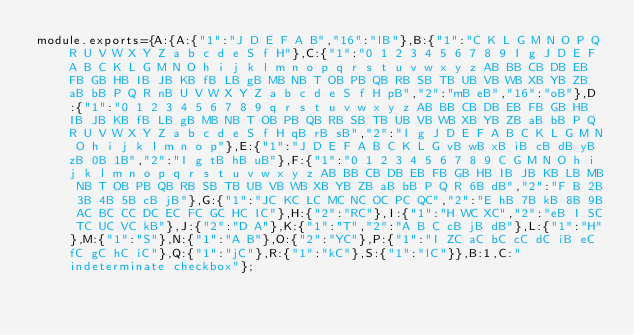<code> <loc_0><loc_0><loc_500><loc_500><_JavaScript_>module.exports={A:{A:{"1":"J D E F A B","16":"lB"},B:{"1":"C K L G M N O P Q R U V W X Y Z a b c d e S f H"},C:{"1":"0 1 2 3 4 5 6 7 8 9 I g J D E F A B C K L G M N O h i j k l m n o p q r s t u v w x y z AB BB CB DB EB FB GB HB IB JB KB fB LB gB MB NB T OB PB QB RB SB TB UB VB WB XB YB ZB aB bB P Q R nB U V W X Y Z a b c d e S f H pB","2":"mB eB","16":"oB"},D:{"1":"0 1 2 3 4 5 6 7 8 9 q r s t u v w x y z AB BB CB DB EB FB GB HB IB JB KB fB LB gB MB NB T OB PB QB RB SB TB UB VB WB XB YB ZB aB bB P Q R U V W X Y Z a b c d e S f H qB rB sB","2":"I g J D E F A B C K L G M N O h i j k l m n o p"},E:{"1":"J D E F A B C K L G vB wB xB iB cB dB yB zB 0B 1B","2":"I g tB hB uB"},F:{"1":"0 1 2 3 4 5 6 7 8 9 C G M N O h i j k l m n o p q r s t u v w x y z AB BB CB DB EB FB GB HB IB JB KB LB MB NB T OB PB QB RB SB TB UB VB WB XB YB ZB aB bB P Q R 6B dB","2":"F B 2B 3B 4B 5B cB jB"},G:{"1":"JC KC LC MC NC OC PC QC","2":"E hB 7B kB 8B 9B AC BC CC DC EC FC GC HC IC"},H:{"2":"RC"},I:{"1":"H WC XC","2":"eB I SC TC UC VC kB"},J:{"2":"D A"},K:{"1":"T","2":"A B C cB jB dB"},L:{"1":"H"},M:{"1":"S"},N:{"1":"A B"},O:{"2":"YC"},P:{"1":"I ZC aC bC cC dC iB eC fC gC hC iC"},Q:{"1":"jC"},R:{"1":"kC"},S:{"1":"lC"}},B:1,C:"indeterminate checkbox"};
</code> 